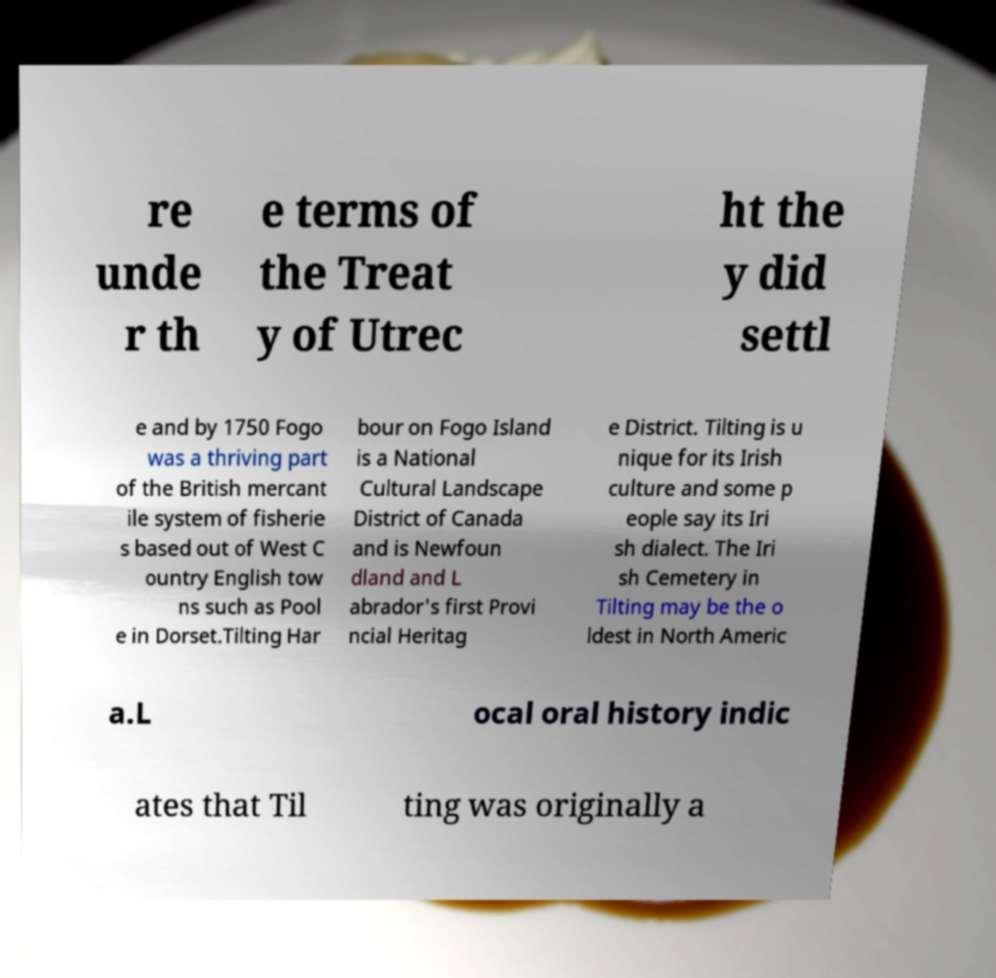Please identify and transcribe the text found in this image. re unde r th e terms of the Treat y of Utrec ht the y did settl e and by 1750 Fogo was a thriving part of the British mercant ile system of fisherie s based out of West C ountry English tow ns such as Pool e in Dorset.Tilting Har bour on Fogo Island is a National Cultural Landscape District of Canada and is Newfoun dland and L abrador's first Provi ncial Heritag e District. Tilting is u nique for its Irish culture and some p eople say its Iri sh dialect. The Iri sh Cemetery in Tilting may be the o ldest in North Americ a.L ocal oral history indic ates that Til ting was originally a 